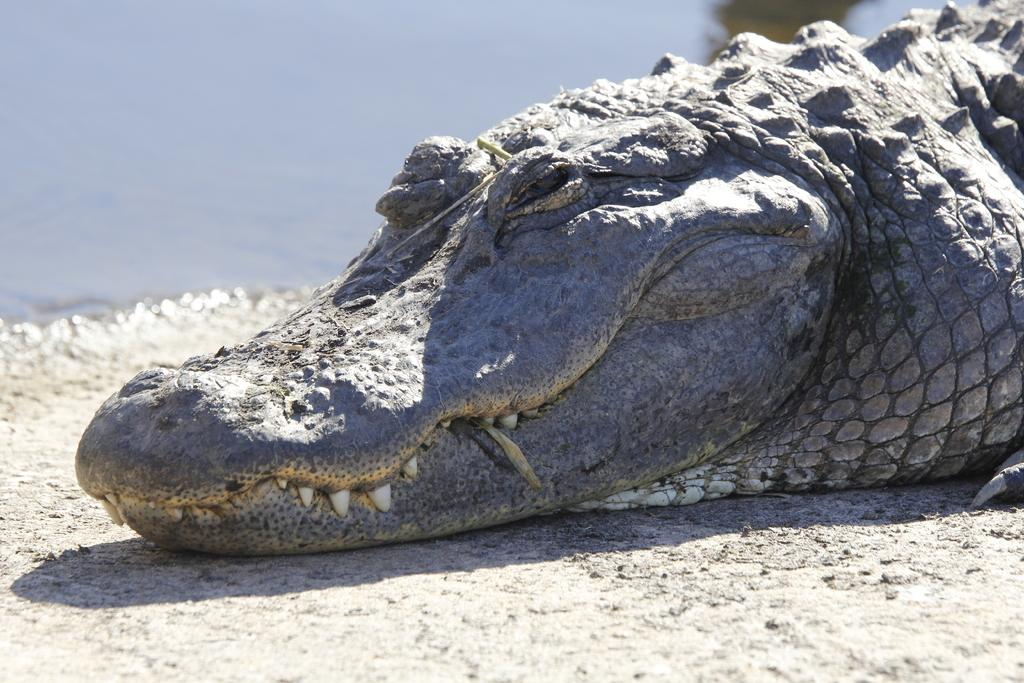What animal is present on the surface in the image? There is a crocodile on the surface in the image. What type of environment is depicted in the image? The image shows a crocodile on a surface with water visible in the background. What type of window can be seen in the image? There is no window present in the image; it features a crocodile on a surface with water visible in the background. 